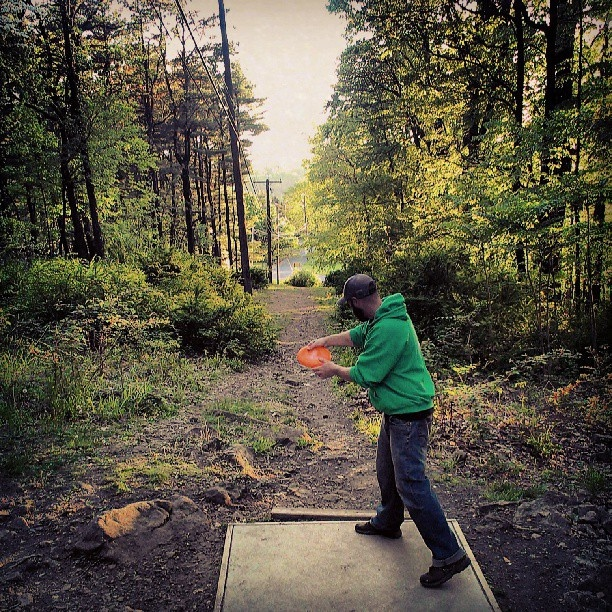Describe the objects in this image and their specific colors. I can see people in black, teal, green, and gray tones, frisbee in black, salmon, and red tones, people in black and tan tones, and people in black, olive, khaki, tan, and maroon tones in this image. 